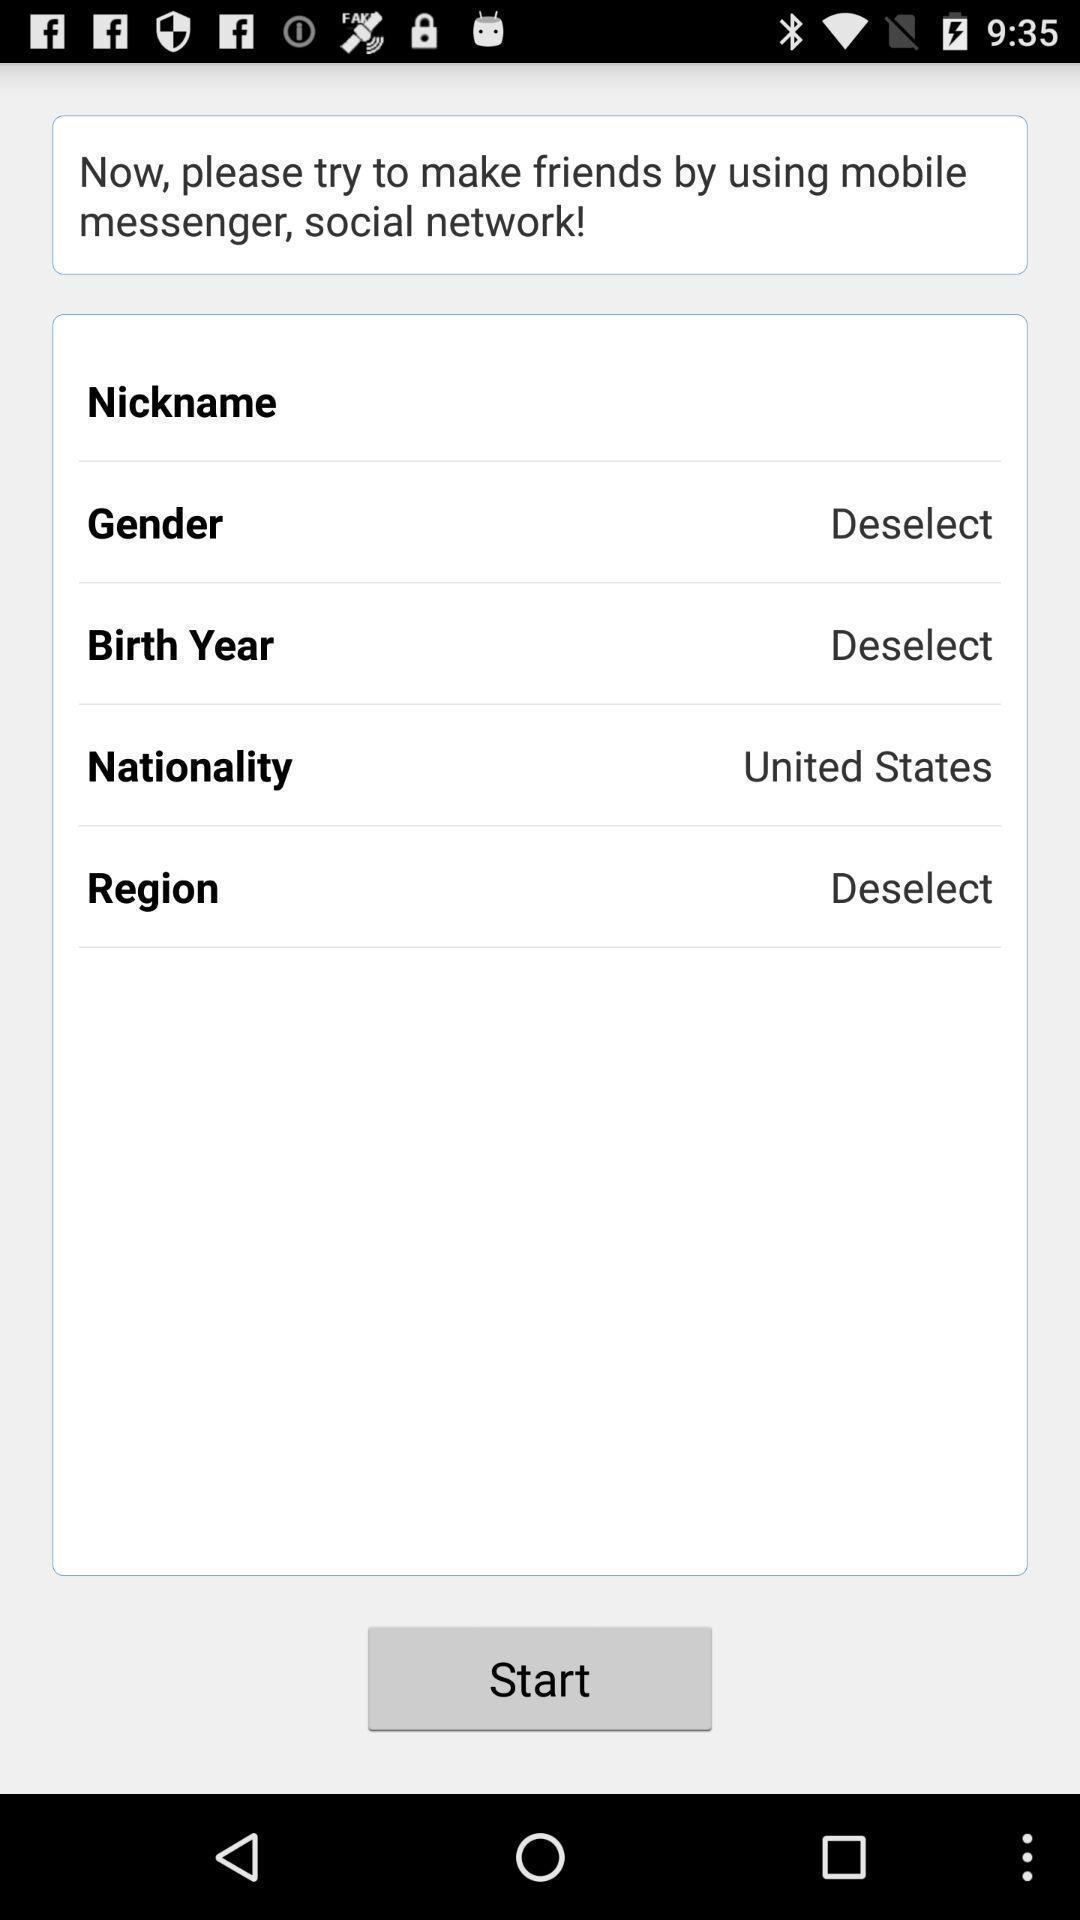Explain what's happening in this screen capture. Window displaying a message app. 